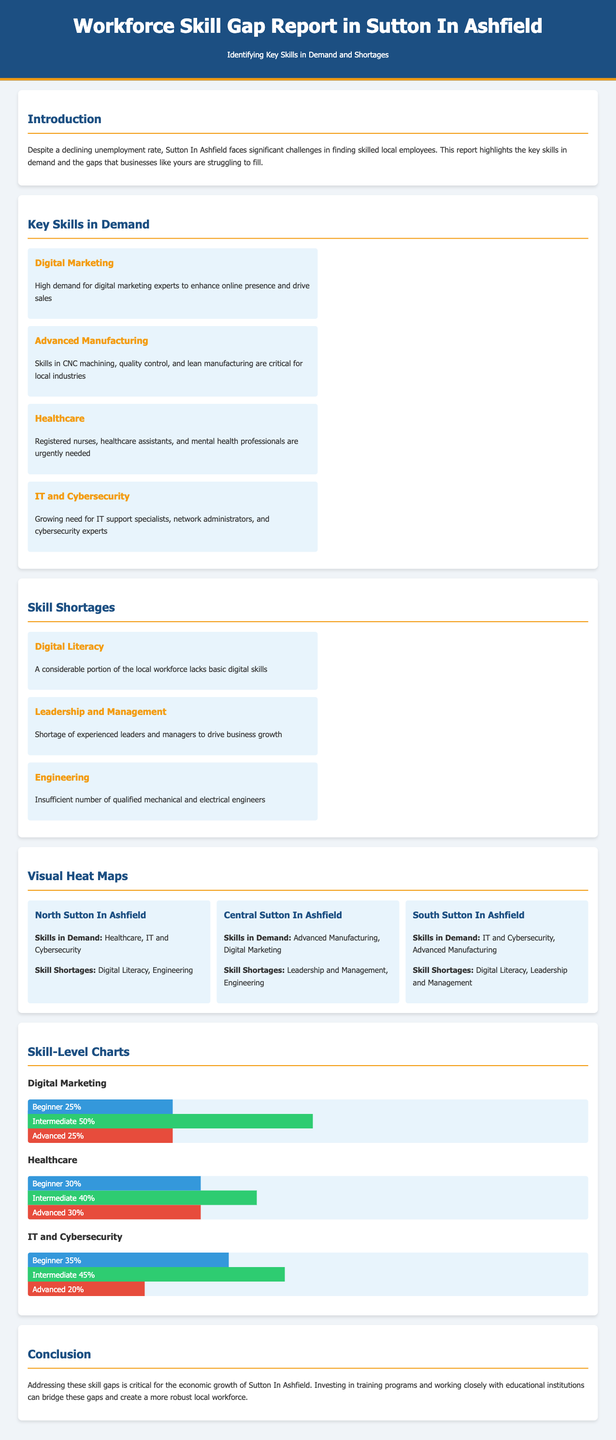What are the key skills in demand? The document lists the skills that are currently sought after in Sutton In Ashfield.
Answer: Digital Marketing, Advanced Manufacturing, Healthcare, IT and Cybersecurity What skill is in shortage under Central Sutton In Ashfield? The section on skill shortages provides details on shortages in different regions.
Answer: Leadership and Management What percentage of beginners in Digital Marketing are there? The skill-level chart shows the distribution of skill levels for Digital Marketing.
Answer: 25% Which region has a high demand for IT and Cybersecurity skills? The visual heat maps indicate the regions with specific skill demands.
Answer: South Sutton In Ashfield How many skills are identified as shortages in the document? The section on skill shortages lists the specific skills that are lacking in the local workforce.
Answer: 3 What is the total percentage of advanced skill level in IT and Cybersecurity? The skill-level chart for IT and Cybersecurity specifies the percentage of advanced skills.
Answer: 20% Which sector urgently needs registered nurses? The key skills in demand section highlights what specific roles are needed in healthcare.
Answer: Healthcare 